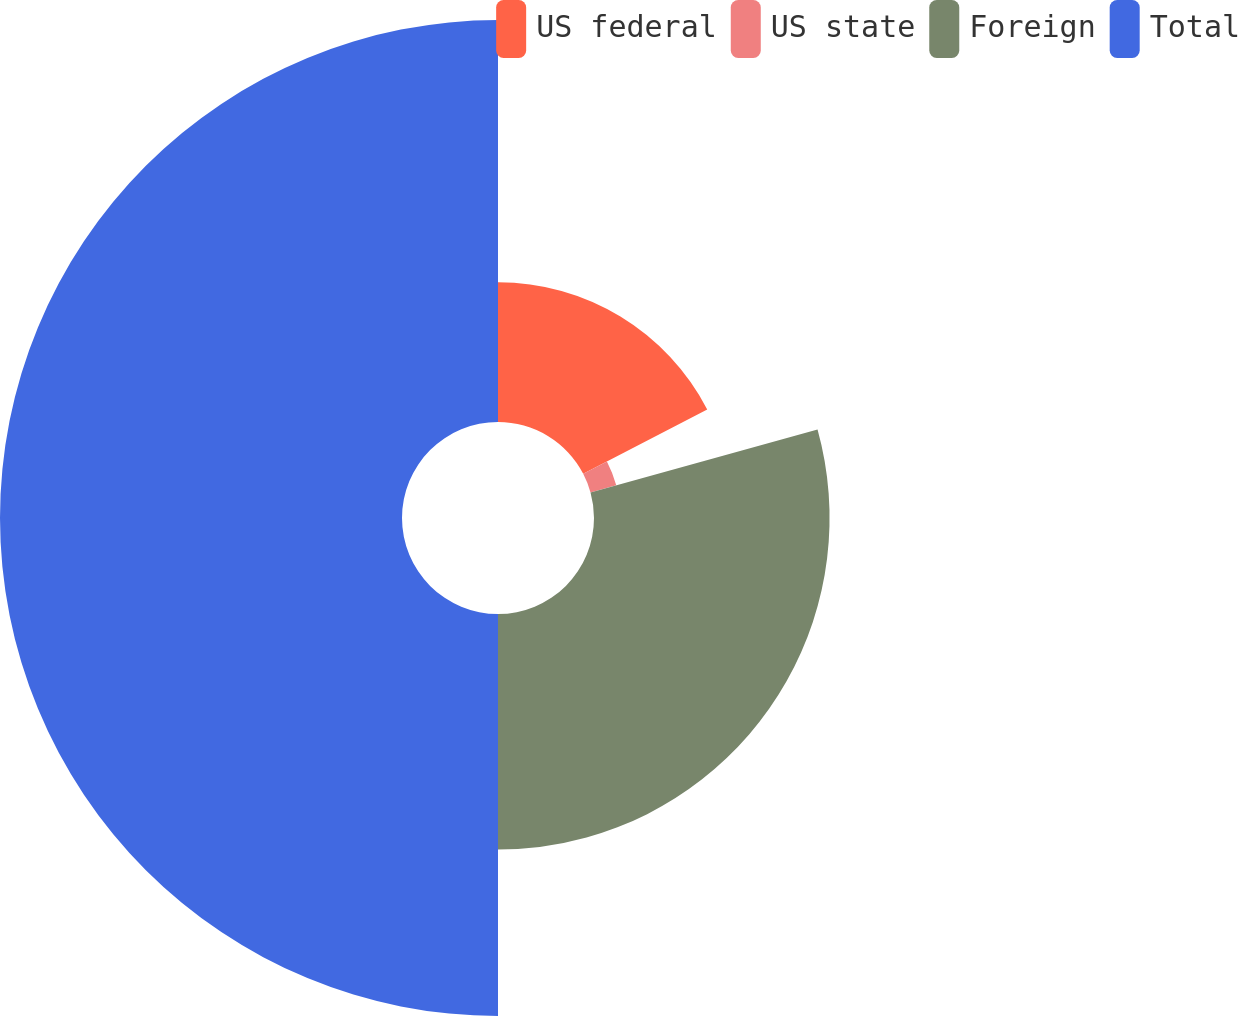Convert chart. <chart><loc_0><loc_0><loc_500><loc_500><pie_chart><fcel>US federal<fcel>US state<fcel>Foreign<fcel>Total<nl><fcel>17.38%<fcel>3.32%<fcel>29.3%<fcel>50.0%<nl></chart> 